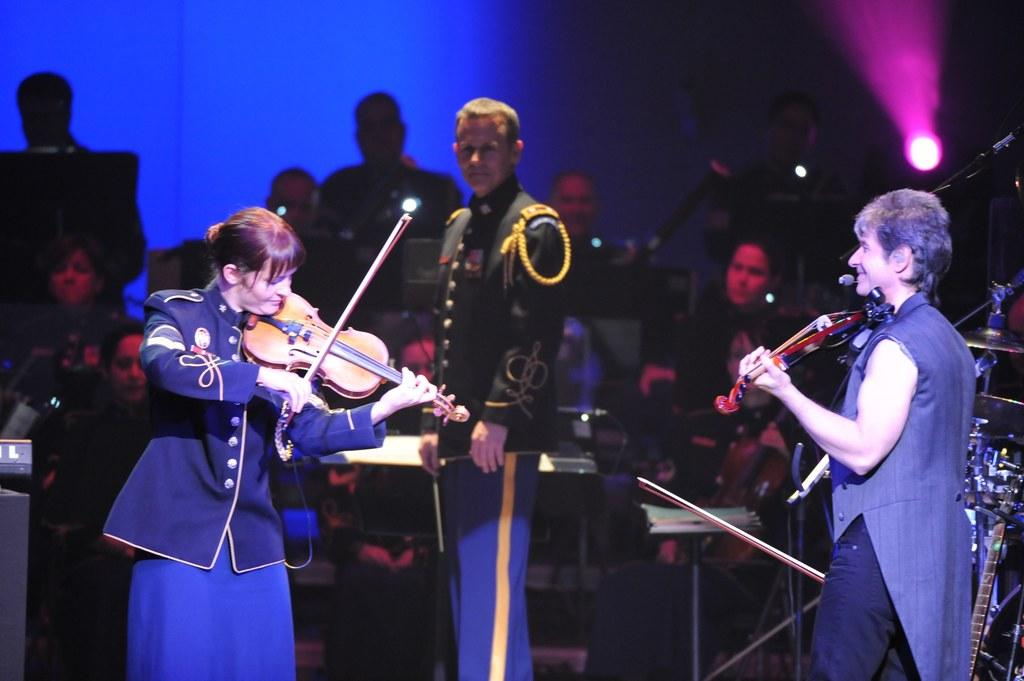How many people are present in the image? There are many people in the image. What are the two women doing in the image? The two women are playing violins. What are the other people in the image doing? The remaining people are playing musical instruments. Can you see a knife being used by anyone in the image? No, there is no knife present in the image. Is there a dog playing a musical instrument in the image? No, there are no animals, including dogs, present in the image. 